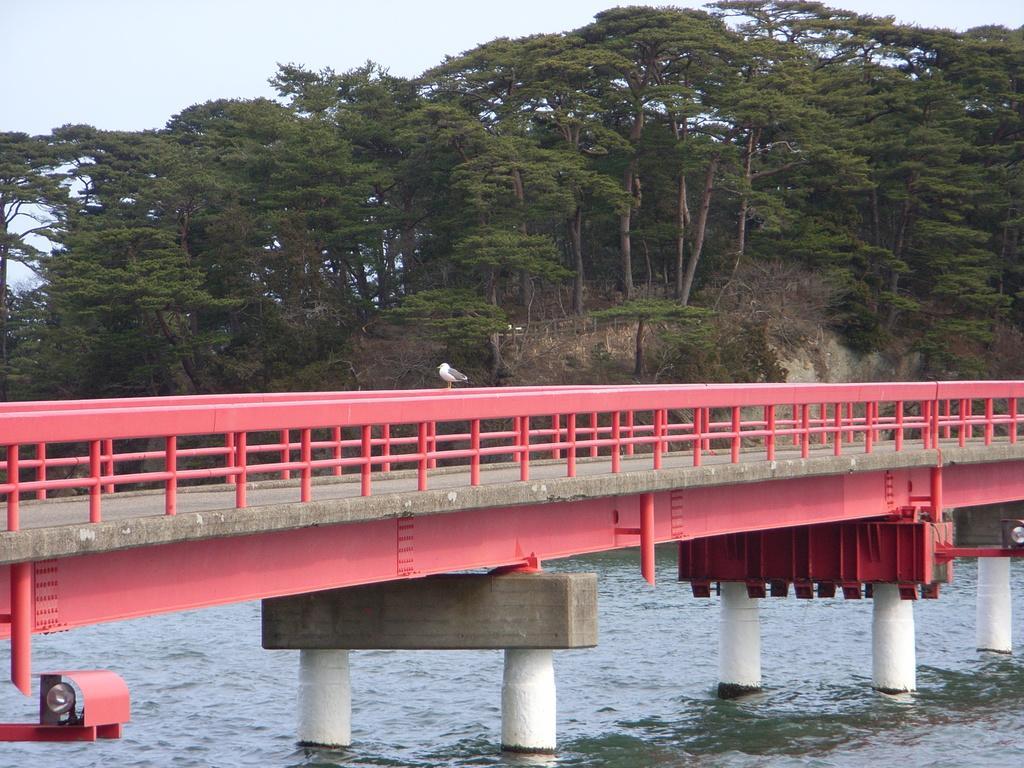In one or two sentences, can you explain what this image depicts? There is a bridge on which there is a bird. There is water below it. There are trees at the back. 